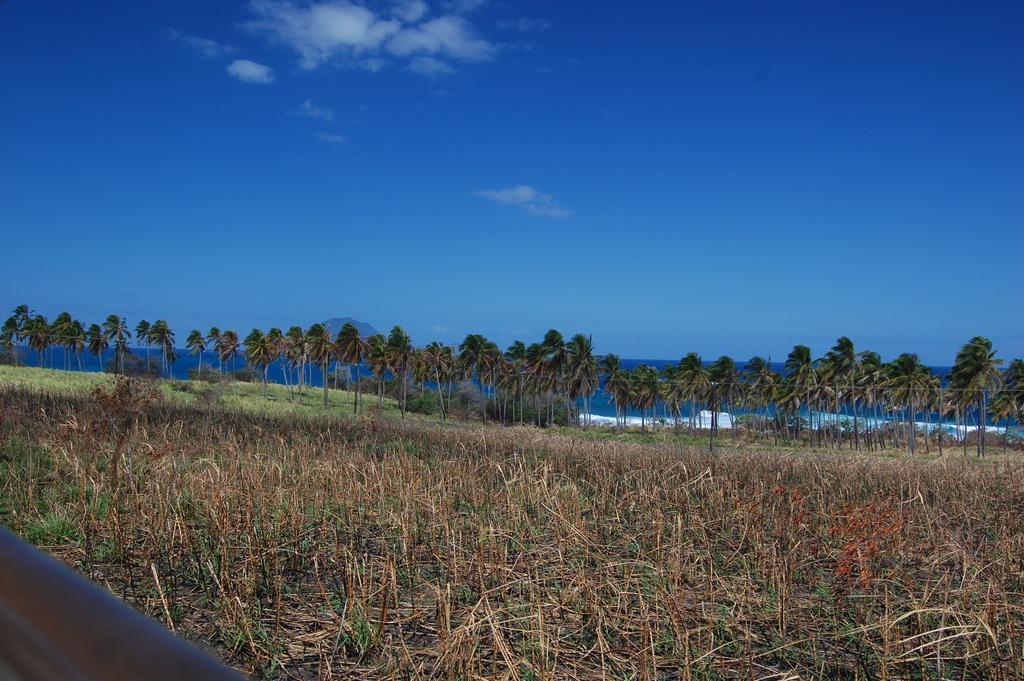What type of vegetation is present on the ground in the image? There are plants on the ground in the image. What other types of vegetation can be seen in the image? There are trees in the image. What is the ground covered with in the image? There is grass in the image. What can be seen in the background of the image? There is water, a mountain, and the sky visible in the background of the image. What books are being read by the plants in the image? There are no books present in the image, as it features plants, trees, grass, water, a mountain, and the sky. 